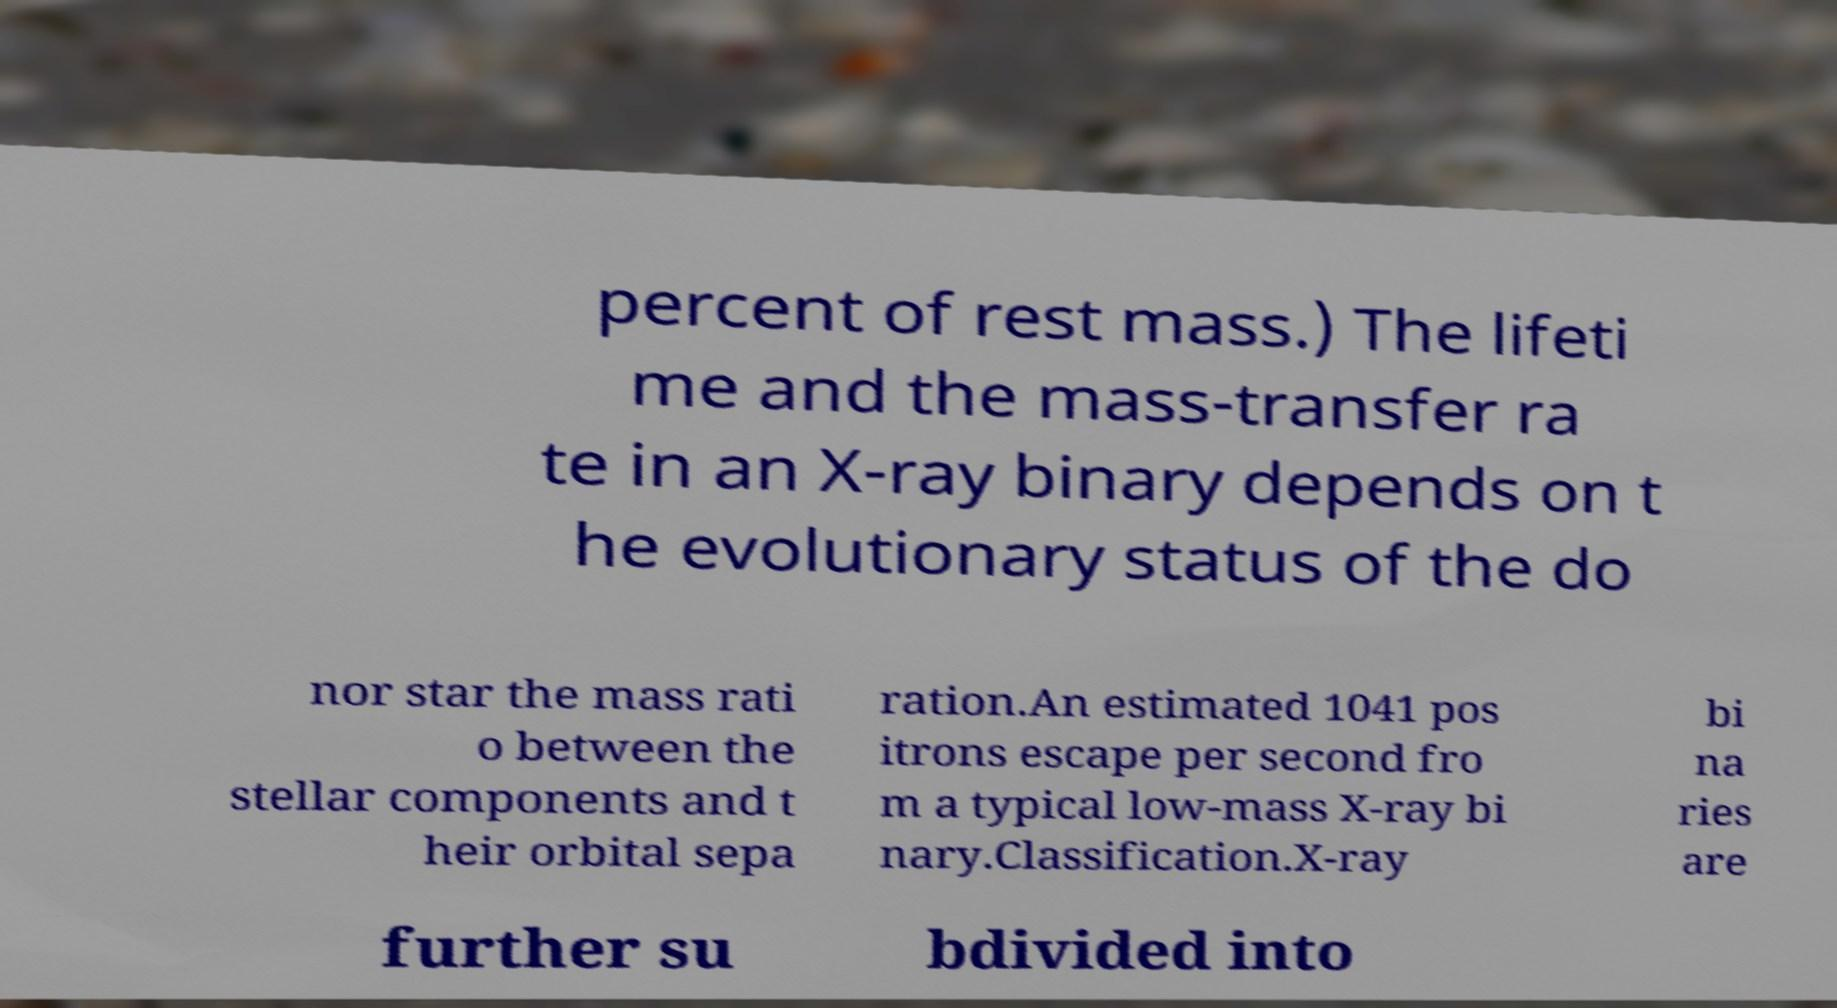For documentation purposes, I need the text within this image transcribed. Could you provide that? percent of rest mass.) The lifeti me and the mass-transfer ra te in an X-ray binary depends on t he evolutionary status of the do nor star the mass rati o between the stellar components and t heir orbital sepa ration.An estimated 1041 pos itrons escape per second fro m a typical low-mass X-ray bi nary.Classification.X-ray bi na ries are further su bdivided into 